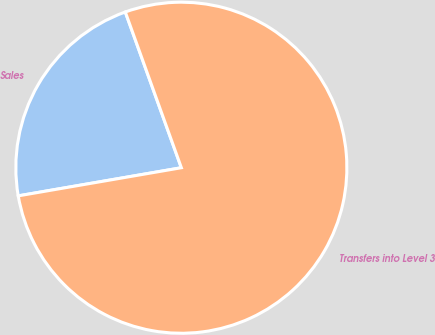Convert chart. <chart><loc_0><loc_0><loc_500><loc_500><pie_chart><fcel>Sales<fcel>Transfers into Level 3<nl><fcel>22.22%<fcel>77.78%<nl></chart> 